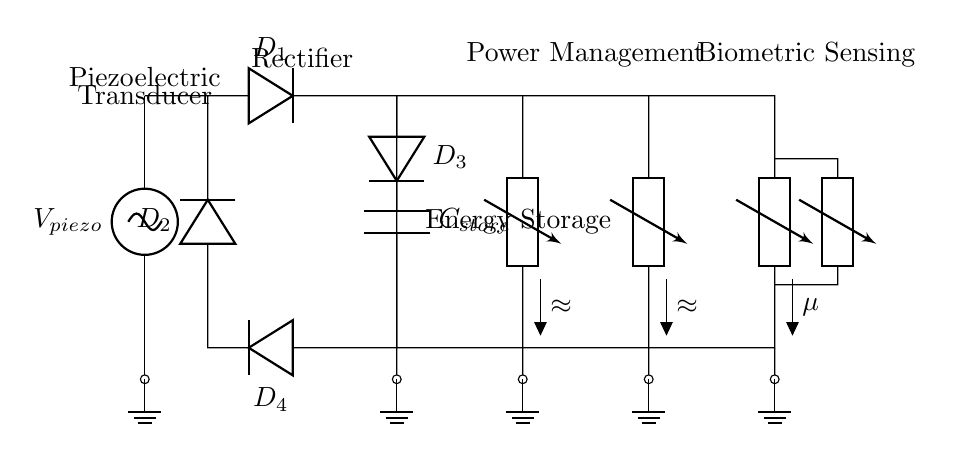What is the type of energy source used in this circuit? The source indicated is a piezoelectric transducer, which converts mechanical energy into electrical energy. This is specified above the symbol for the voltage source in the circuit diagram.
Answer: Piezoelectric How many diodes are in the rectifier bridge? There are four diodes in the rectifier bridge: D1, D2, D3, and D4. This is shown in the circuit, where the diodes are sequentially connected to form a bridge configuration.
Answer: Four What is the purpose of the capacitor in this circuit? The capacitor labeled C_store is used for energy storage, which allows it to store the harvested energy from the piezoelectric transducer for later use. This function is indicated by the label next to the capacitor.
Answer: Energy Storage What is the function of the DC-DC converter in this circuit? The DC-DC converter is used to adjust the voltage level of the stored energy to meet the operational requirements of the attached components. Its placement in the circuit, indicated above with a label, shows it as a crucial part of the power management system.
Answer: Voltage Regulation Which component manages the power after the DC-DC converter? The LDO, or low-dropout regulator, follows the DC-DC converter and is responsible for ensuring a stable supply voltage to the microcontroller and sensors. This is indicated by the labeled component in the circuit diagram.
Answer: Low-dropout Regulator What type of sensors are used in this circuit? The sensors indicated are biometric sensors, which are implied by the label connected to the microcontroller, designed to monitor various physical parameters of the athlete.
Answer: Biometric 